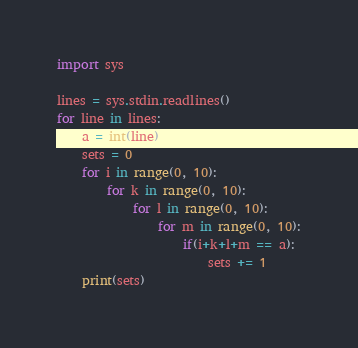<code> <loc_0><loc_0><loc_500><loc_500><_Python_>import sys

lines = sys.stdin.readlines()
for line in lines:
    a = int(line)
    sets = 0
    for i in range(0, 10):
        for k in range(0, 10):
            for l in range(0, 10):
                for m in range(0, 10):
                    if(i+k+l+m == a):
                        sets += 1
    print(sets)

</code> 